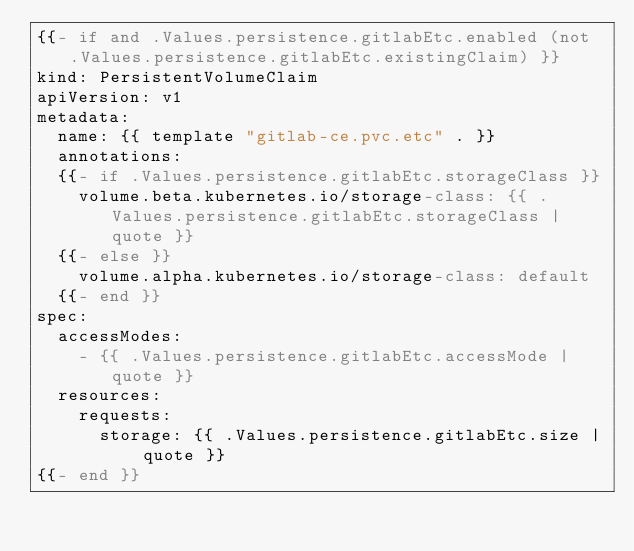<code> <loc_0><loc_0><loc_500><loc_500><_YAML_>{{- if and .Values.persistence.gitlabEtc.enabled (not .Values.persistence.gitlabEtc.existingClaim) }}
kind: PersistentVolumeClaim
apiVersion: v1
metadata:
  name: {{ template "gitlab-ce.pvc.etc" . }}
  annotations:
  {{- if .Values.persistence.gitlabEtc.storageClass }}
    volume.beta.kubernetes.io/storage-class: {{ .Values.persistence.gitlabEtc.storageClass | quote }}
  {{- else }}
    volume.alpha.kubernetes.io/storage-class: default
  {{- end }}
spec:
  accessModes:
    - {{ .Values.persistence.gitlabEtc.accessMode | quote }}
  resources:
    requests:
      storage: {{ .Values.persistence.gitlabEtc.size | quote }}
{{- end }}
</code> 